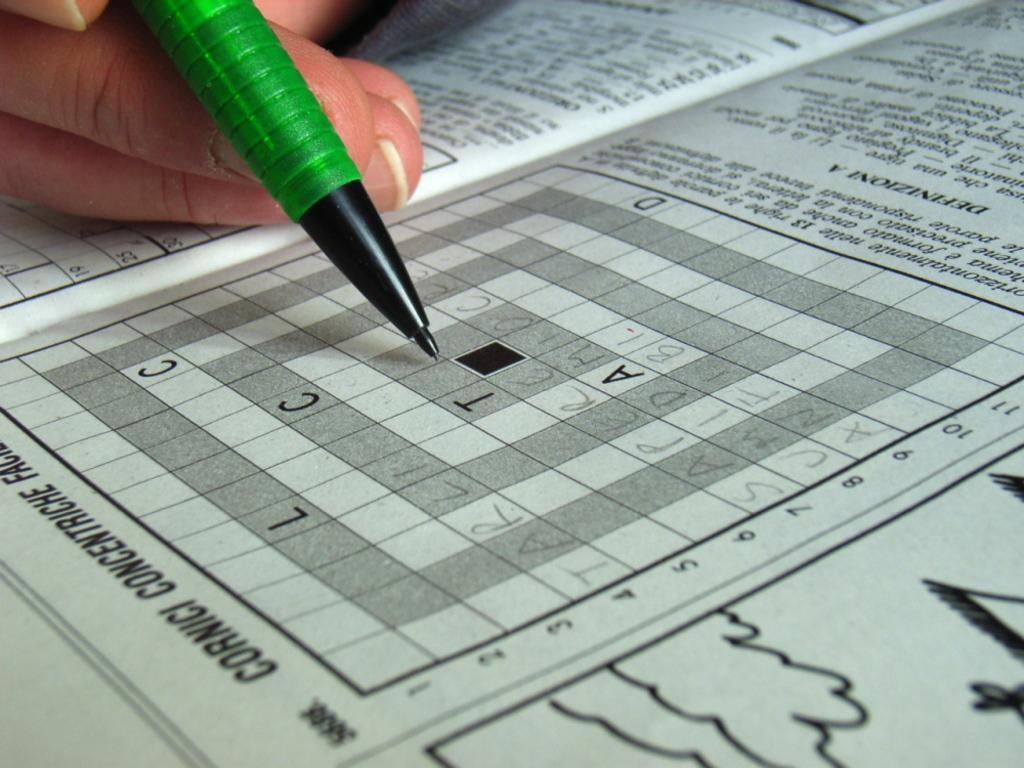What is the person in the image doing? The person is doing a puzzle in a newspaper. What object is the person holding while doing the puzzle? The person is holding a pencil. Where is the newspaper located in the image? The newspaper is on a table in the image. What type of fire can be seen burning on the island in the image? There is no fire or island present in the image; it features a person doing a puzzle in a newspaper. What is the zinc content of the pencil being held by the person in the image? The zinc content of the pencil cannot be determined from the image, as it does not provide information about the pencil's composition. 